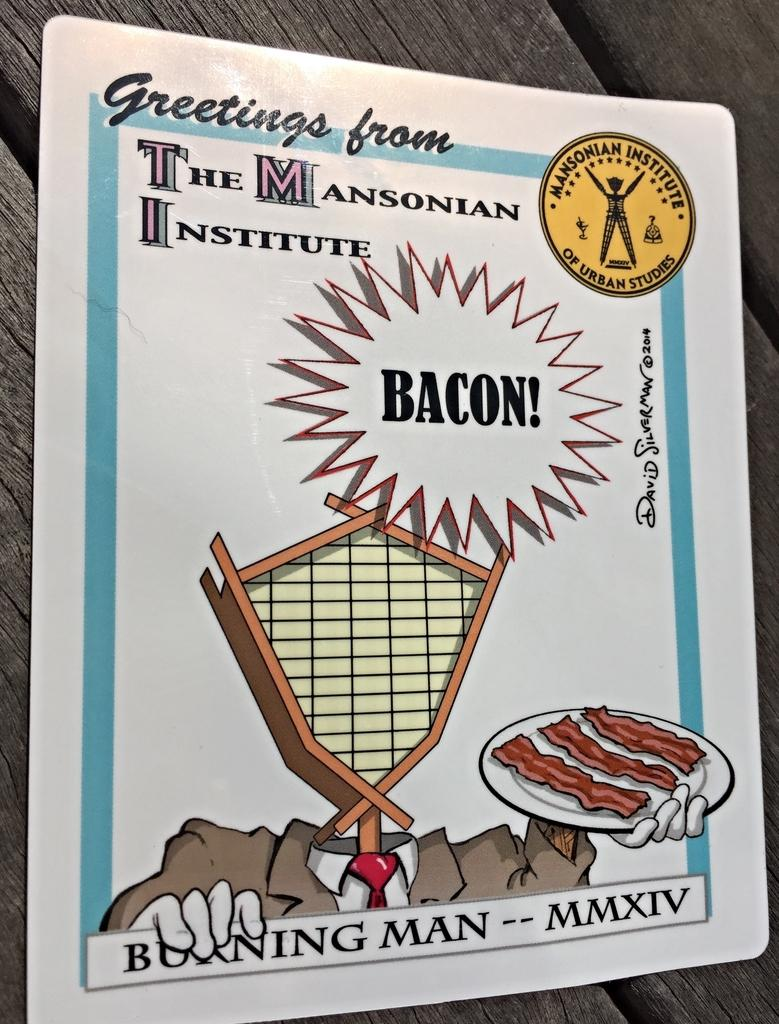What is present in the image that can be written or drawn on? There is a paper in the image that can be written or drawn on. What type of content is on the paper? The paper contains animated figures. Are there any words or letters on the paper? Yes, there is text written on the paper. What type of shoe is depicted in the animated figures on the paper? There are no shoes depicted in the animated figures on the paper; the paper contains animated figures but does not show any specific objects like shoes. 